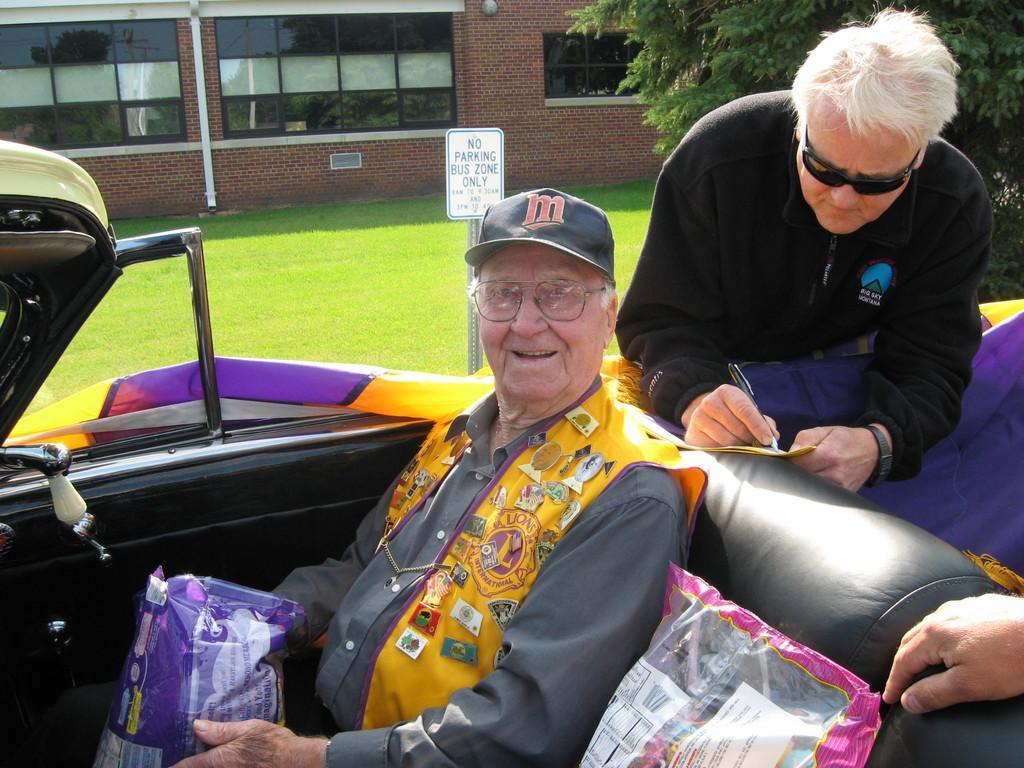Can you describe this image briefly? In the picture I can see a person wearing hat is sitting in a vehicle and holding an object in his hands and there is another person wearing black dress is writing something behind him and there is a hand of a person in the right corner and there is a greenery ground,a tree and a building in the background. 